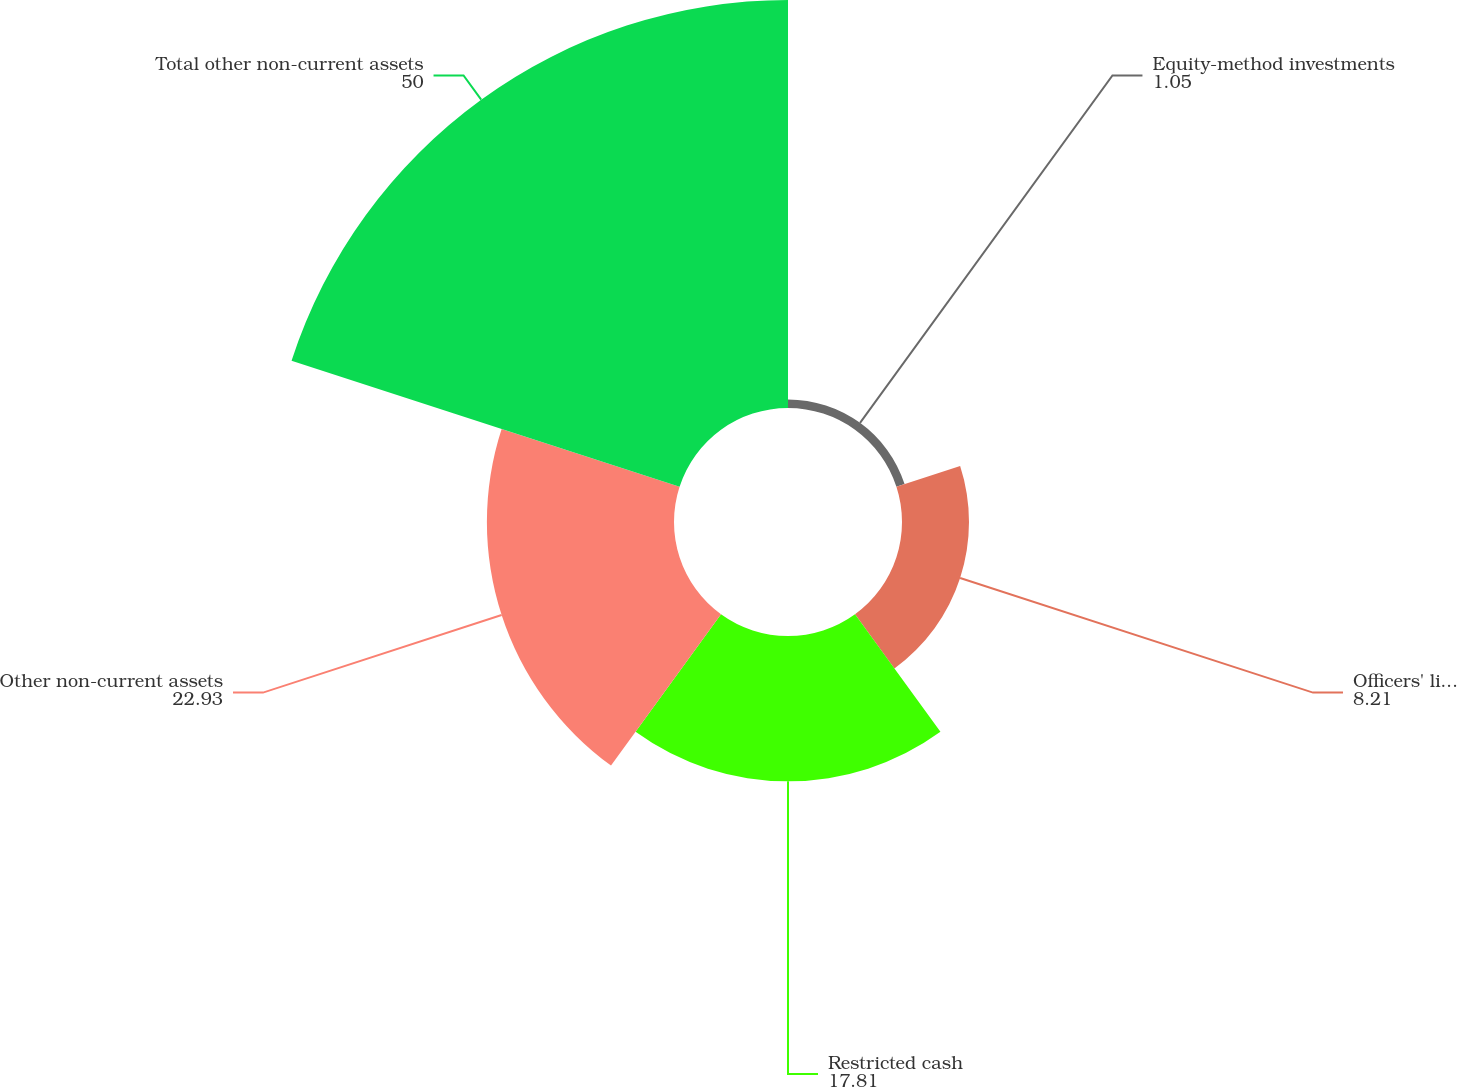Convert chart to OTSL. <chart><loc_0><loc_0><loc_500><loc_500><pie_chart><fcel>Equity-method investments<fcel>Officers' life insurance<fcel>Restricted cash<fcel>Other non-current assets<fcel>Total other non-current assets<nl><fcel>1.05%<fcel>8.21%<fcel>17.81%<fcel>22.93%<fcel>50.0%<nl></chart> 